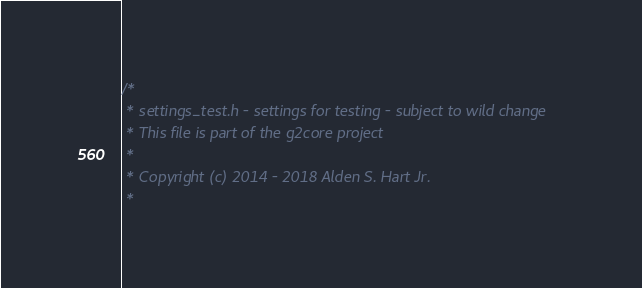<code> <loc_0><loc_0><loc_500><loc_500><_C_>/*
 * settings_test.h - settings for testing - subject to wild change
 * This file is part of the g2core project
 *
 * Copyright (c) 2014 - 2018 Alden S. Hart Jr.
 *</code> 